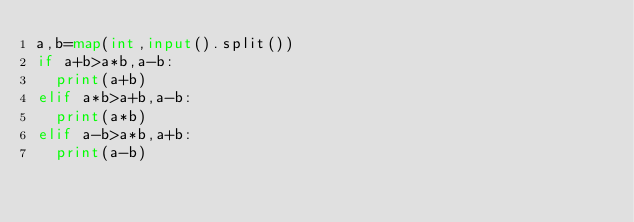<code> <loc_0><loc_0><loc_500><loc_500><_Python_>a,b=map(int,input().split())
if a+b>a*b,a-b:
  print(a+b)
elif a*b>a+b,a-b:
  print(a*b)
elif a-b>a*b,a+b:
  print(a-b)</code> 